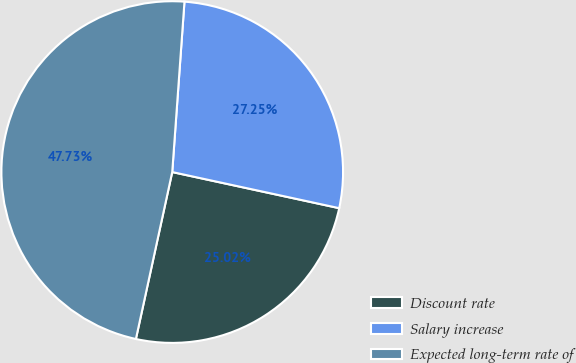Convert chart. <chart><loc_0><loc_0><loc_500><loc_500><pie_chart><fcel>Discount rate<fcel>Salary increase<fcel>Expected long-term rate of<nl><fcel>25.02%<fcel>27.25%<fcel>47.73%<nl></chart> 